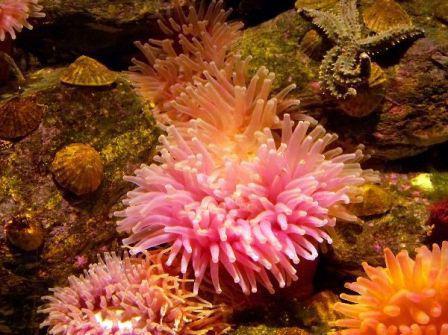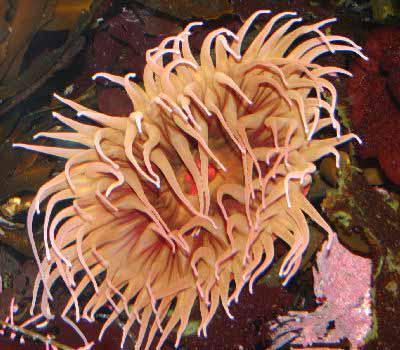The first image is the image on the left, the second image is the image on the right. Examine the images to the left and right. Is the description "An image shows multipe individual orange anemone and no other color anemone." accurate? Answer yes or no. No. 